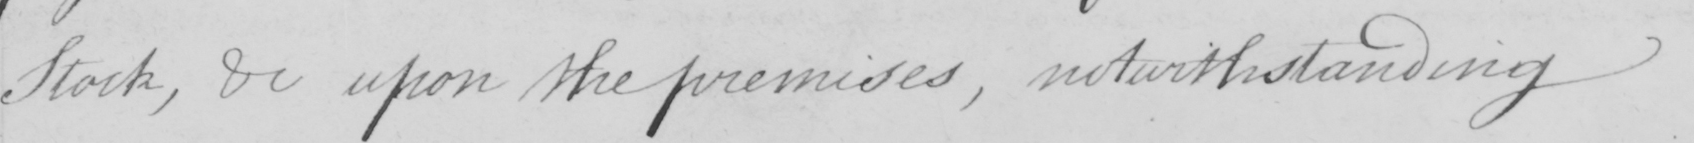Transcribe the text shown in this historical manuscript line. Stock , &c upon the premises , notwithstanding 